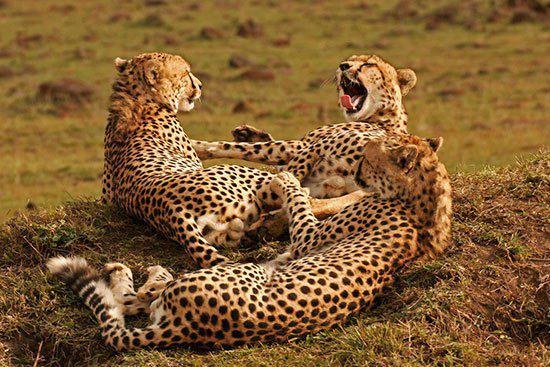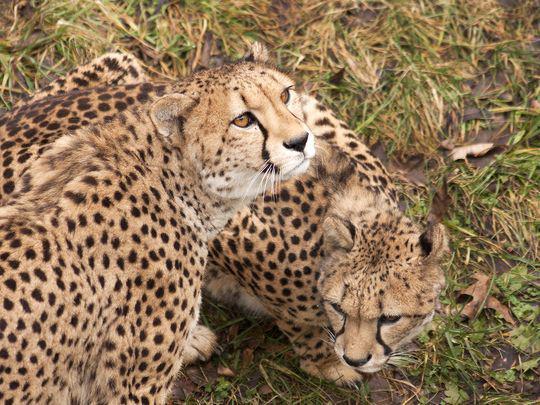The first image is the image on the left, the second image is the image on the right. Given the left and right images, does the statement "In one of the images, you can see one of the animal's tongues." hold true? Answer yes or no. Yes. The first image is the image on the left, the second image is the image on the right. Considering the images on both sides, is "There are more spotted wild cats in the left image than in the right." valid? Answer yes or no. Yes. 